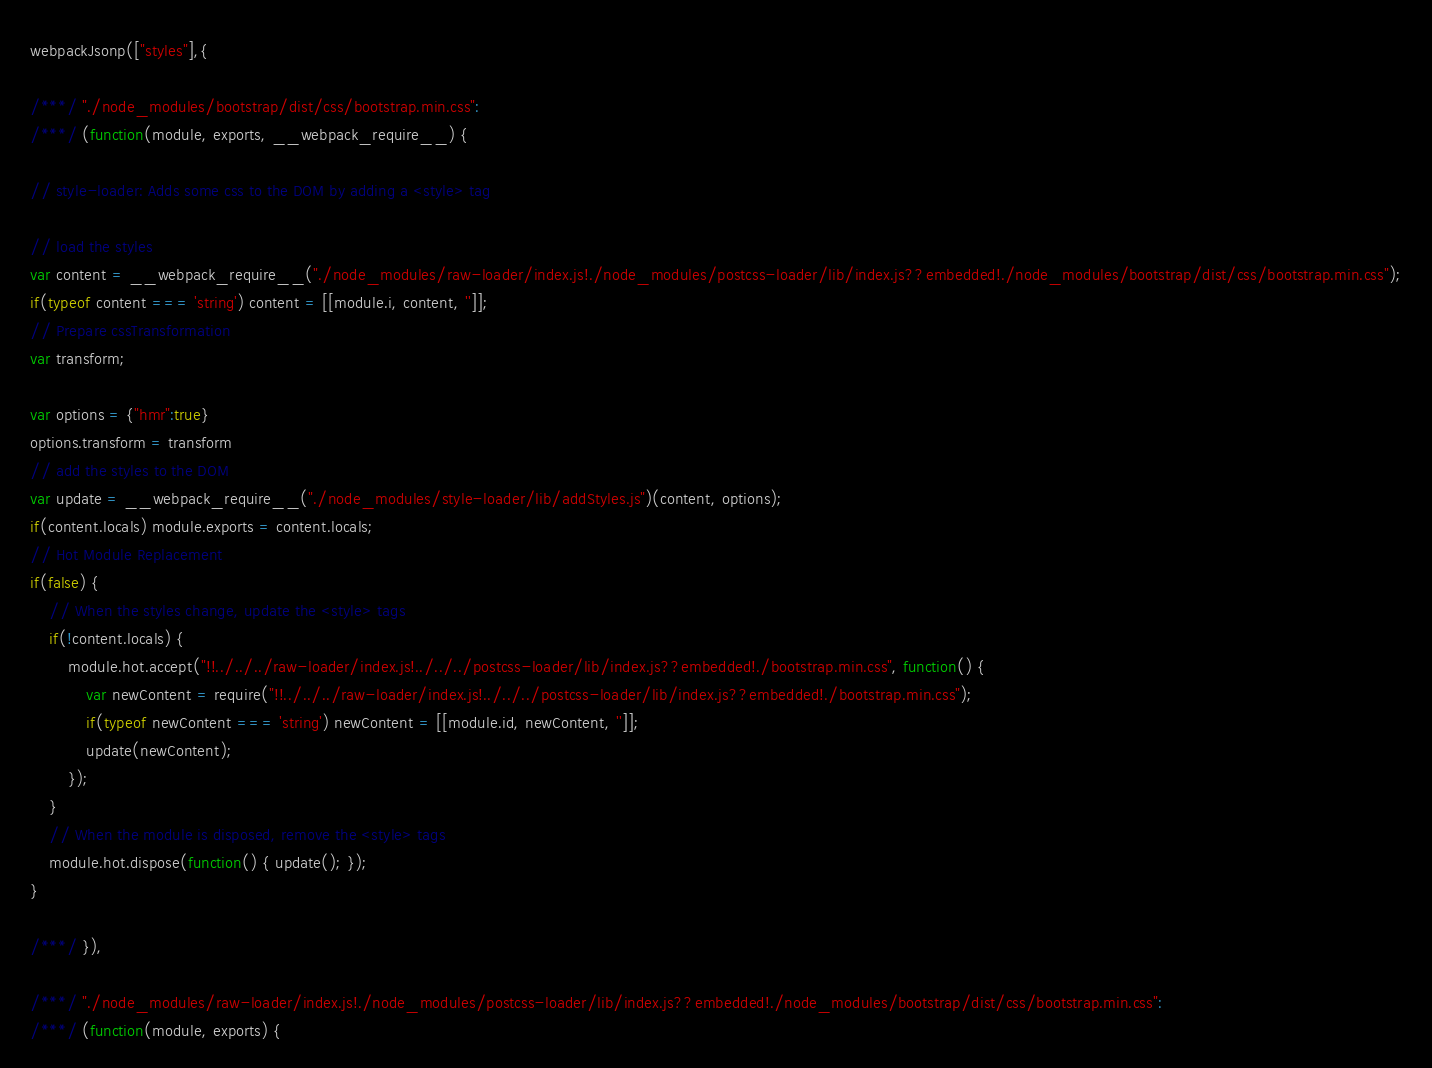<code> <loc_0><loc_0><loc_500><loc_500><_JavaScript_>webpackJsonp(["styles"],{

/***/ "./node_modules/bootstrap/dist/css/bootstrap.min.css":
/***/ (function(module, exports, __webpack_require__) {

// style-loader: Adds some css to the DOM by adding a <style> tag

// load the styles
var content = __webpack_require__("./node_modules/raw-loader/index.js!./node_modules/postcss-loader/lib/index.js??embedded!./node_modules/bootstrap/dist/css/bootstrap.min.css");
if(typeof content === 'string') content = [[module.i, content, '']];
// Prepare cssTransformation
var transform;

var options = {"hmr":true}
options.transform = transform
// add the styles to the DOM
var update = __webpack_require__("./node_modules/style-loader/lib/addStyles.js")(content, options);
if(content.locals) module.exports = content.locals;
// Hot Module Replacement
if(false) {
	// When the styles change, update the <style> tags
	if(!content.locals) {
		module.hot.accept("!!../../../raw-loader/index.js!../../../postcss-loader/lib/index.js??embedded!./bootstrap.min.css", function() {
			var newContent = require("!!../../../raw-loader/index.js!../../../postcss-loader/lib/index.js??embedded!./bootstrap.min.css");
			if(typeof newContent === 'string') newContent = [[module.id, newContent, '']];
			update(newContent);
		});
	}
	// When the module is disposed, remove the <style> tags
	module.hot.dispose(function() { update(); });
}

/***/ }),

/***/ "./node_modules/raw-loader/index.js!./node_modules/postcss-loader/lib/index.js??embedded!./node_modules/bootstrap/dist/css/bootstrap.min.css":
/***/ (function(module, exports) {
</code> 